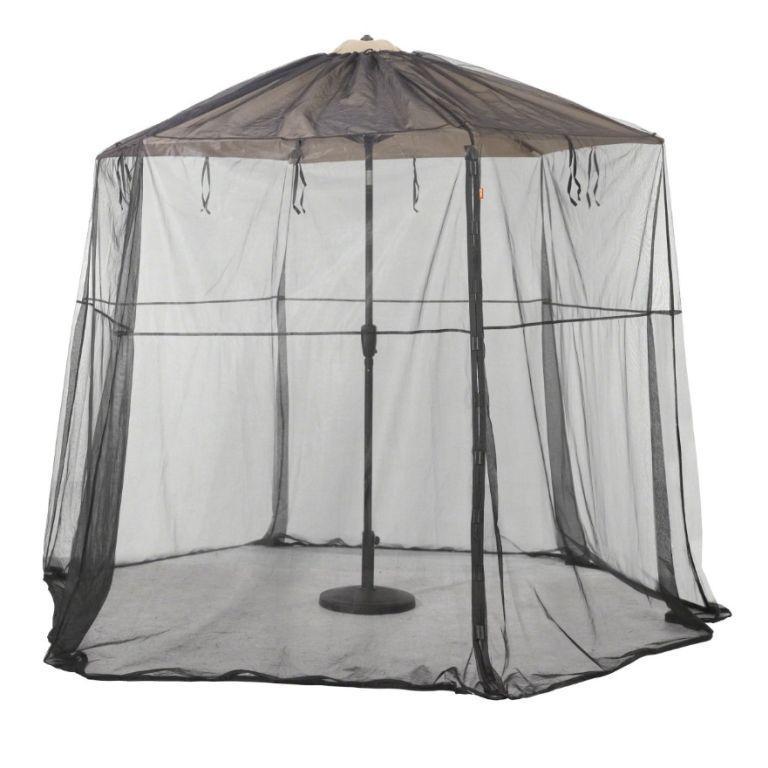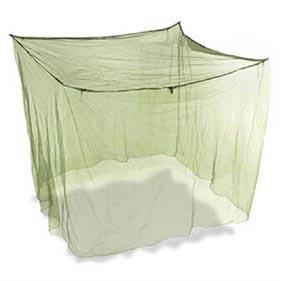The first image is the image on the left, the second image is the image on the right. For the images shown, is this caption "The tents are both empty." true? Answer yes or no. Yes. The first image is the image on the left, the second image is the image on the right. Assess this claim about the two images: "There are two canopies with at least one mostly square one.". Correct or not? Answer yes or no. Yes. 